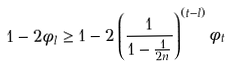Convert formula to latex. <formula><loc_0><loc_0><loc_500><loc_500>1 - 2 \phi _ { l } \geq 1 - 2 \left ( \frac { 1 } { 1 - \frac { 1 } { 2 n } } \right ) ^ { ( t - l ) } \phi _ { t }</formula> 